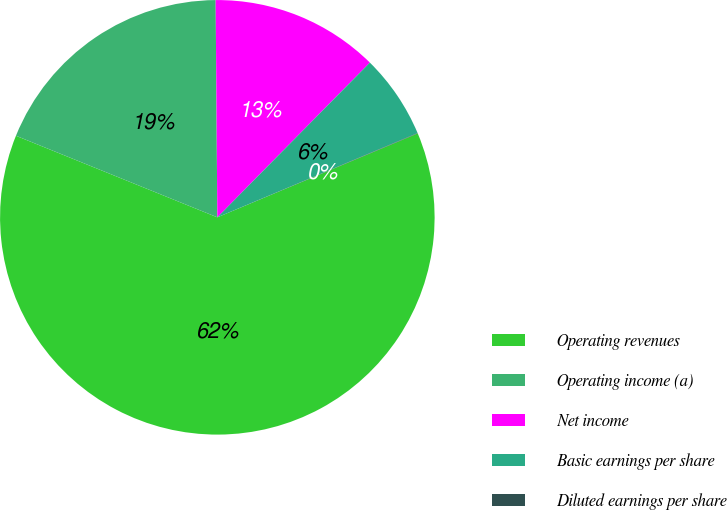<chart> <loc_0><loc_0><loc_500><loc_500><pie_chart><fcel>Operating revenues<fcel>Operating income (a)<fcel>Net income<fcel>Basic earnings per share<fcel>Diluted earnings per share<nl><fcel>62.43%<fcel>18.75%<fcel>12.51%<fcel>6.27%<fcel>0.03%<nl></chart> 